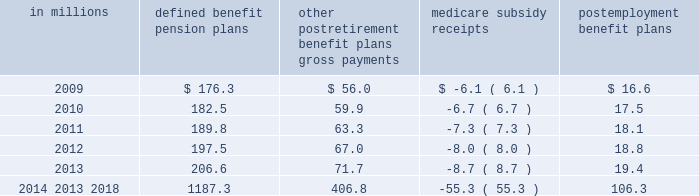Contributions and future benefit payments we expect to make contributions of $ 28.1 million to our defined benefit , other postretirement , and postemployment benefits plans in fiscal 2009 .
Actual 2009 contributions could exceed our current projections , as influenced by our decision to undertake discretionary funding of our benefit trusts versus other competing investment priorities and future changes in government requirements .
Estimated benefit payments , which reflect expected future service , as appropriate , are expected to be paid from fiscal 2009-2018 as follows : in millions defined benefit pension postretirement benefit plans gross payments medicare subsidy receipts postemployment benefit ......................................................................................................................................................................................... .
Defined contribution plans the general mills savings plan is a defined contribution plan that covers salaried and nonunion employees .
It had net assets of $ 2309.9 million as of may 25 , 2008 and $ 2303.0 million as of may 27 , 2007.this plan is a 401 ( k ) savings plan that includes a number of investment funds and an employee stock ownership plan ( esop ) .
We sponsor another savings plan for certain hourly employees with net assets of $ 16.0 million as of may 25 , 2008 .
Our total recognized expense related to defined contribution plans was $ 61.9 million in fiscal 2008 , $ 48.3 million in fiscal 2007 , and $ 45.5 million in fiscal 2006 .
The esop originally purchased our common stock principally with funds borrowed from third parties and guaranteed by us.the esop shares are included in net shares outstanding for the purposes of calculating eps .
The esop 2019s third-party debt was repaid on june 30 , 2007 .
The esop 2019s only assets are our common stock and temporary cash balances.the esop 2019s share of the total defined contribution expense was $ 52.3 million in fiscal 2008 , $ 40.1 million in fiscal 2007 , and $ 37.6 million in fiscal 2006 .
The esop 2019s expensewas calculated by the 201cshares allocated 201dmethod .
The esop used our common stock to convey benefits to employees and , through increased stock ownership , to further align employee interests with those of stockholders.wematched a percentage of employee contributions to the general mills savings plan with a base match plus a variable year end match that depended on annual results .
Employees received our match in the form of common stock .
Our cash contribution to the esop was calculated so as to pay off enough debt to release sufficient shares to make our match .
The esop used our cash contributions to the plan , plus the dividends received on the esop 2019s leveraged shares , to make principal and interest payments on the esop 2019s debt .
As loan payments were made , shares became unencumbered by debt and were committed to be allocated .
The esop allocated shares to individual employee accounts on the basis of the match of employee payroll savings ( contributions ) , plus reinvested dividends received on previously allocated shares .
The esop incurred net interest of less than $ 1.0 million in each of fiscal 2007 and 2006 .
The esop used dividends of $ 2.5 million in fiscal 2007 and $ 3.9 million in 2006 , along with our contributions of less than $ 1.0 million in each of fiscal 2007 and 2006 to make interest and principal payments .
The number of shares of our common stock allocated to participants in the esop was 5.2 million as of may 25 , 2008 , and 5.4 million as of may 27 , 2007 .
Annual report 2008 81 .
What was the average total recognized expense related to defined contribution plans from 2006 to 2008? 
Computations: (((61.9 + 48.3) + 45.5) / 3)
Answer: 51.9. 